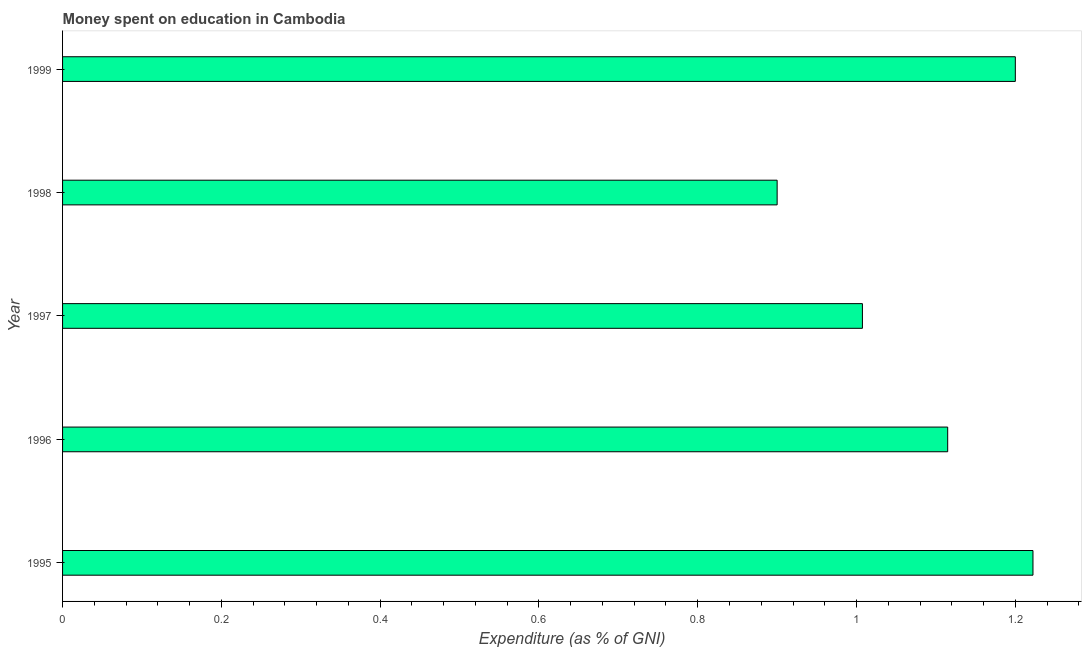What is the title of the graph?
Ensure brevity in your answer.  Money spent on education in Cambodia. What is the label or title of the X-axis?
Your response must be concise. Expenditure (as % of GNI). What is the expenditure on education in 1998?
Give a very brief answer. 0.9. Across all years, what is the maximum expenditure on education?
Provide a short and direct response. 1.22. In which year was the expenditure on education maximum?
Offer a terse response. 1995. In which year was the expenditure on education minimum?
Your answer should be very brief. 1998. What is the sum of the expenditure on education?
Your answer should be very brief. 5.44. What is the difference between the expenditure on education in 1995 and 1997?
Give a very brief answer. 0.21. What is the average expenditure on education per year?
Ensure brevity in your answer.  1.09. What is the median expenditure on education?
Offer a terse response. 1.11. What is the ratio of the expenditure on education in 1998 to that in 1999?
Provide a succinct answer. 0.75. Is the expenditure on education in 1996 less than that in 1997?
Ensure brevity in your answer.  No. What is the difference between the highest and the second highest expenditure on education?
Ensure brevity in your answer.  0.02. Is the sum of the expenditure on education in 1996 and 1998 greater than the maximum expenditure on education across all years?
Provide a short and direct response. Yes. What is the difference between the highest and the lowest expenditure on education?
Keep it short and to the point. 0.32. How many bars are there?
Your response must be concise. 5. Are all the bars in the graph horizontal?
Your answer should be compact. Yes. Are the values on the major ticks of X-axis written in scientific E-notation?
Your answer should be compact. No. What is the Expenditure (as % of GNI) in 1995?
Keep it short and to the point. 1.22. What is the Expenditure (as % of GNI) of 1996?
Provide a short and direct response. 1.11. What is the Expenditure (as % of GNI) in 1997?
Keep it short and to the point. 1.01. What is the Expenditure (as % of GNI) of 1998?
Give a very brief answer. 0.9. What is the Expenditure (as % of GNI) of 1999?
Keep it short and to the point. 1.2. What is the difference between the Expenditure (as % of GNI) in 1995 and 1996?
Ensure brevity in your answer.  0.11. What is the difference between the Expenditure (as % of GNI) in 1995 and 1997?
Provide a succinct answer. 0.21. What is the difference between the Expenditure (as % of GNI) in 1995 and 1998?
Offer a very short reply. 0.32. What is the difference between the Expenditure (as % of GNI) in 1995 and 1999?
Your answer should be compact. 0.02. What is the difference between the Expenditure (as % of GNI) in 1996 and 1997?
Give a very brief answer. 0.11. What is the difference between the Expenditure (as % of GNI) in 1996 and 1998?
Offer a terse response. 0.21. What is the difference between the Expenditure (as % of GNI) in 1996 and 1999?
Your answer should be compact. -0.09. What is the difference between the Expenditure (as % of GNI) in 1997 and 1998?
Your response must be concise. 0.11. What is the difference between the Expenditure (as % of GNI) in 1997 and 1999?
Your answer should be very brief. -0.19. What is the difference between the Expenditure (as % of GNI) in 1998 and 1999?
Your answer should be compact. -0.3. What is the ratio of the Expenditure (as % of GNI) in 1995 to that in 1996?
Ensure brevity in your answer.  1.1. What is the ratio of the Expenditure (as % of GNI) in 1995 to that in 1997?
Give a very brief answer. 1.21. What is the ratio of the Expenditure (as % of GNI) in 1995 to that in 1998?
Ensure brevity in your answer.  1.36. What is the ratio of the Expenditure (as % of GNI) in 1996 to that in 1997?
Your response must be concise. 1.11. What is the ratio of the Expenditure (as % of GNI) in 1996 to that in 1998?
Provide a short and direct response. 1.24. What is the ratio of the Expenditure (as % of GNI) in 1996 to that in 1999?
Give a very brief answer. 0.93. What is the ratio of the Expenditure (as % of GNI) in 1997 to that in 1998?
Your answer should be compact. 1.12. What is the ratio of the Expenditure (as % of GNI) in 1997 to that in 1999?
Give a very brief answer. 0.84. What is the ratio of the Expenditure (as % of GNI) in 1998 to that in 1999?
Your answer should be compact. 0.75. 